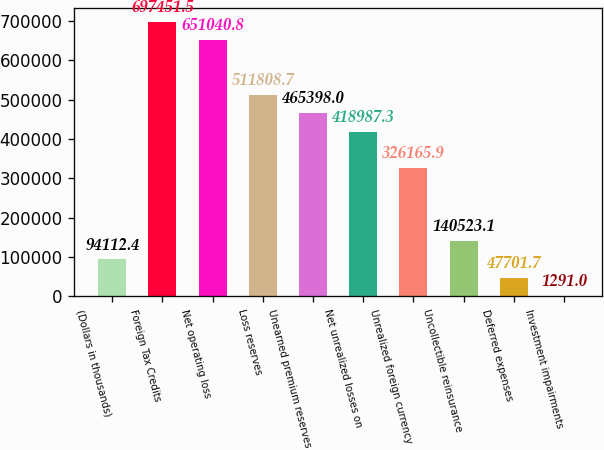<chart> <loc_0><loc_0><loc_500><loc_500><bar_chart><fcel>(Dollars in thousands)<fcel>Foreign Tax Credits<fcel>Net operating loss<fcel>Loss reserves<fcel>Unearned premium reserves<fcel>Net unrealized losses on<fcel>Unrealized foreign currency<fcel>Uncollectible reinsurance<fcel>Deferred expenses<fcel>Investment impairments<nl><fcel>94112.4<fcel>697452<fcel>651041<fcel>511809<fcel>465398<fcel>418987<fcel>326166<fcel>140523<fcel>47701.7<fcel>1291<nl></chart> 